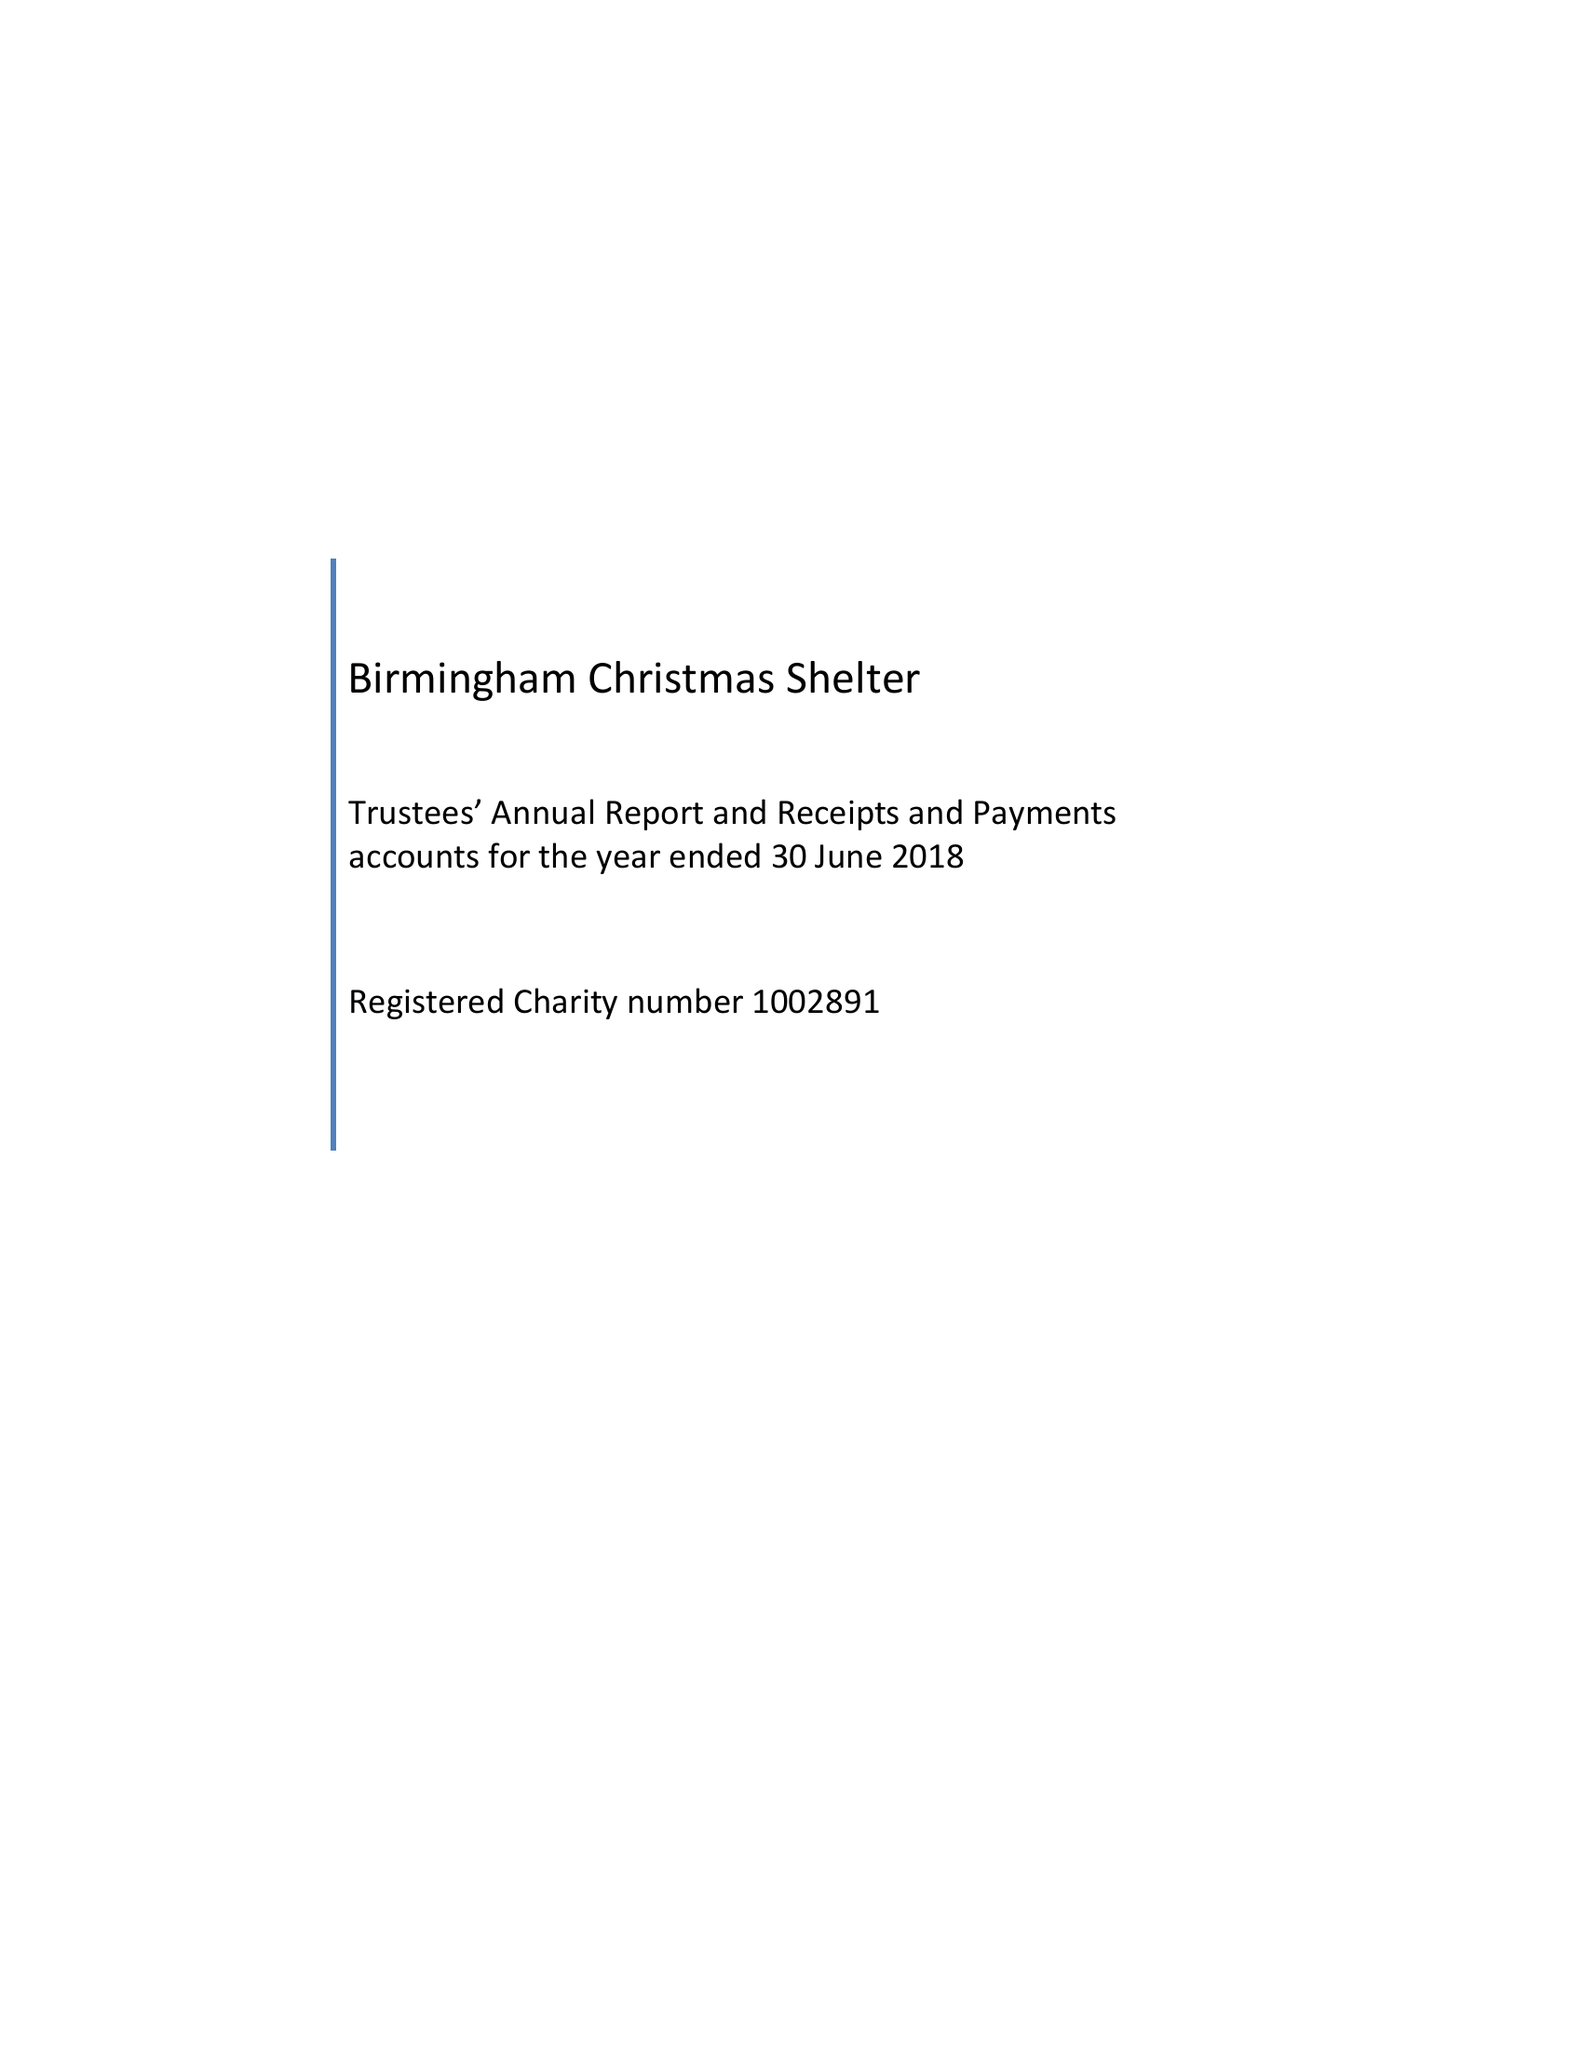What is the value for the income_annually_in_british_pounds?
Answer the question using a single word or phrase. 37706.00 